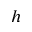Convert formula to latex. <formula><loc_0><loc_0><loc_500><loc_500>h</formula> 